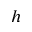Convert formula to latex. <formula><loc_0><loc_0><loc_500><loc_500>h</formula> 